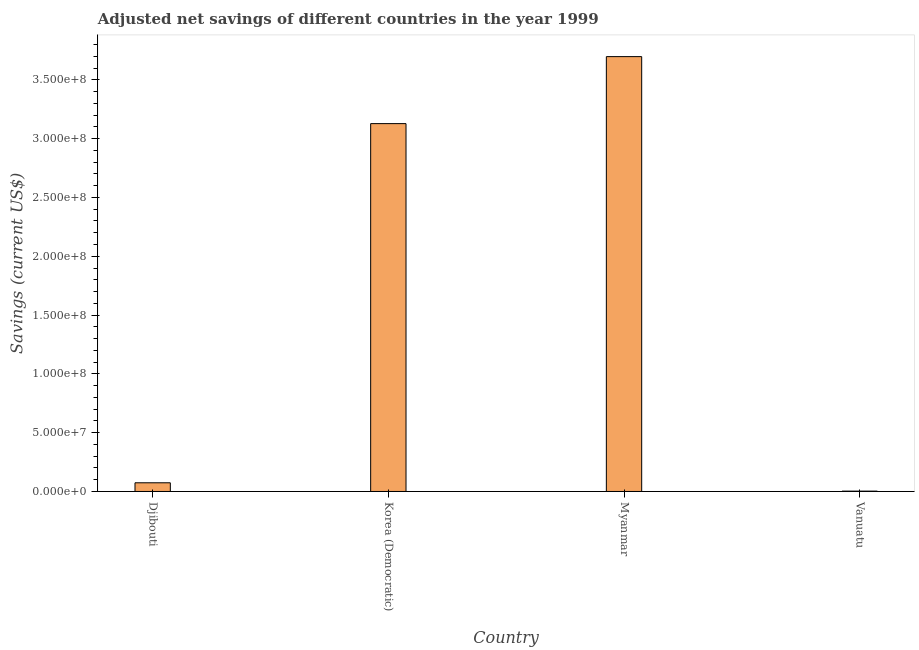Does the graph contain any zero values?
Provide a short and direct response. No. Does the graph contain grids?
Give a very brief answer. No. What is the title of the graph?
Give a very brief answer. Adjusted net savings of different countries in the year 1999. What is the label or title of the Y-axis?
Keep it short and to the point. Savings (current US$). What is the adjusted net savings in Vanuatu?
Provide a short and direct response. 2.90e+05. Across all countries, what is the maximum adjusted net savings?
Make the answer very short. 3.70e+08. Across all countries, what is the minimum adjusted net savings?
Your answer should be compact. 2.90e+05. In which country was the adjusted net savings maximum?
Ensure brevity in your answer.  Myanmar. In which country was the adjusted net savings minimum?
Offer a very short reply. Vanuatu. What is the sum of the adjusted net savings?
Your response must be concise. 6.90e+08. What is the difference between the adjusted net savings in Djibouti and Vanuatu?
Ensure brevity in your answer.  7.09e+06. What is the average adjusted net savings per country?
Make the answer very short. 1.73e+08. What is the median adjusted net savings?
Give a very brief answer. 1.60e+08. In how many countries, is the adjusted net savings greater than 290000000 US$?
Ensure brevity in your answer.  2. What is the ratio of the adjusted net savings in Djibouti to that in Korea (Democratic)?
Offer a very short reply. 0.02. Is the adjusted net savings in Djibouti less than that in Korea (Democratic)?
Your answer should be very brief. Yes. Is the difference between the adjusted net savings in Djibouti and Korea (Democratic) greater than the difference between any two countries?
Offer a very short reply. No. What is the difference between the highest and the second highest adjusted net savings?
Your answer should be very brief. 5.70e+07. Is the sum of the adjusted net savings in Korea (Democratic) and Myanmar greater than the maximum adjusted net savings across all countries?
Provide a short and direct response. Yes. What is the difference between the highest and the lowest adjusted net savings?
Keep it short and to the point. 3.69e+08. In how many countries, is the adjusted net savings greater than the average adjusted net savings taken over all countries?
Give a very brief answer. 2. Are all the bars in the graph horizontal?
Ensure brevity in your answer.  No. What is the difference between two consecutive major ticks on the Y-axis?
Your answer should be very brief. 5.00e+07. Are the values on the major ticks of Y-axis written in scientific E-notation?
Ensure brevity in your answer.  Yes. What is the Savings (current US$) of Djibouti?
Give a very brief answer. 7.38e+06. What is the Savings (current US$) in Korea (Democratic)?
Keep it short and to the point. 3.13e+08. What is the Savings (current US$) in Myanmar?
Give a very brief answer. 3.70e+08. What is the Savings (current US$) in Vanuatu?
Your answer should be compact. 2.90e+05. What is the difference between the Savings (current US$) in Djibouti and Korea (Democratic)?
Your response must be concise. -3.05e+08. What is the difference between the Savings (current US$) in Djibouti and Myanmar?
Make the answer very short. -3.62e+08. What is the difference between the Savings (current US$) in Djibouti and Vanuatu?
Give a very brief answer. 7.09e+06. What is the difference between the Savings (current US$) in Korea (Democratic) and Myanmar?
Ensure brevity in your answer.  -5.70e+07. What is the difference between the Savings (current US$) in Korea (Democratic) and Vanuatu?
Give a very brief answer. 3.12e+08. What is the difference between the Savings (current US$) in Myanmar and Vanuatu?
Make the answer very short. 3.69e+08. What is the ratio of the Savings (current US$) in Djibouti to that in Korea (Democratic)?
Provide a succinct answer. 0.02. What is the ratio of the Savings (current US$) in Djibouti to that in Myanmar?
Your answer should be compact. 0.02. What is the ratio of the Savings (current US$) in Djibouti to that in Vanuatu?
Give a very brief answer. 25.44. What is the ratio of the Savings (current US$) in Korea (Democratic) to that in Myanmar?
Your answer should be compact. 0.85. What is the ratio of the Savings (current US$) in Korea (Democratic) to that in Vanuatu?
Your answer should be compact. 1077.5. What is the ratio of the Savings (current US$) in Myanmar to that in Vanuatu?
Your response must be concise. 1273.74. 